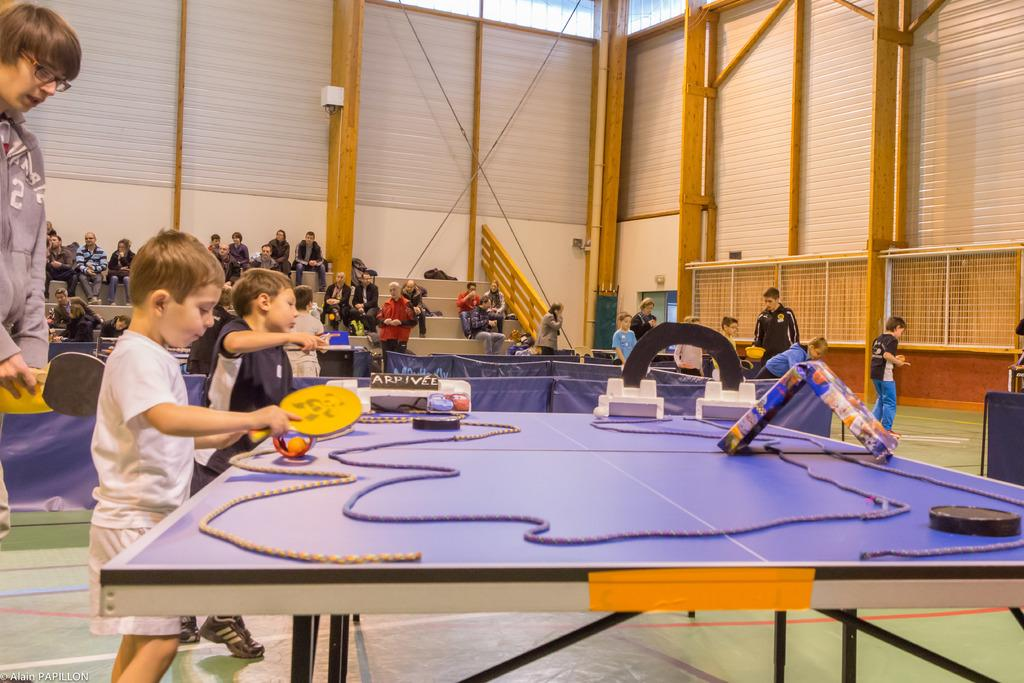How many kids are in the image? There are two kids in the image. What are the kids doing in the image? The kids are playing with bats. What can be seen on the table in the image? There is a rope on the table, along with other things. What is visible in the background of the image? There are people sitting on steps in the background. Who is standing behind one of the kids? A person is standing behind one of the kids. What type of discussion is taking place between the kids and the beast in the image? There is no beast present in the image, and therefore no discussion can be observed. 